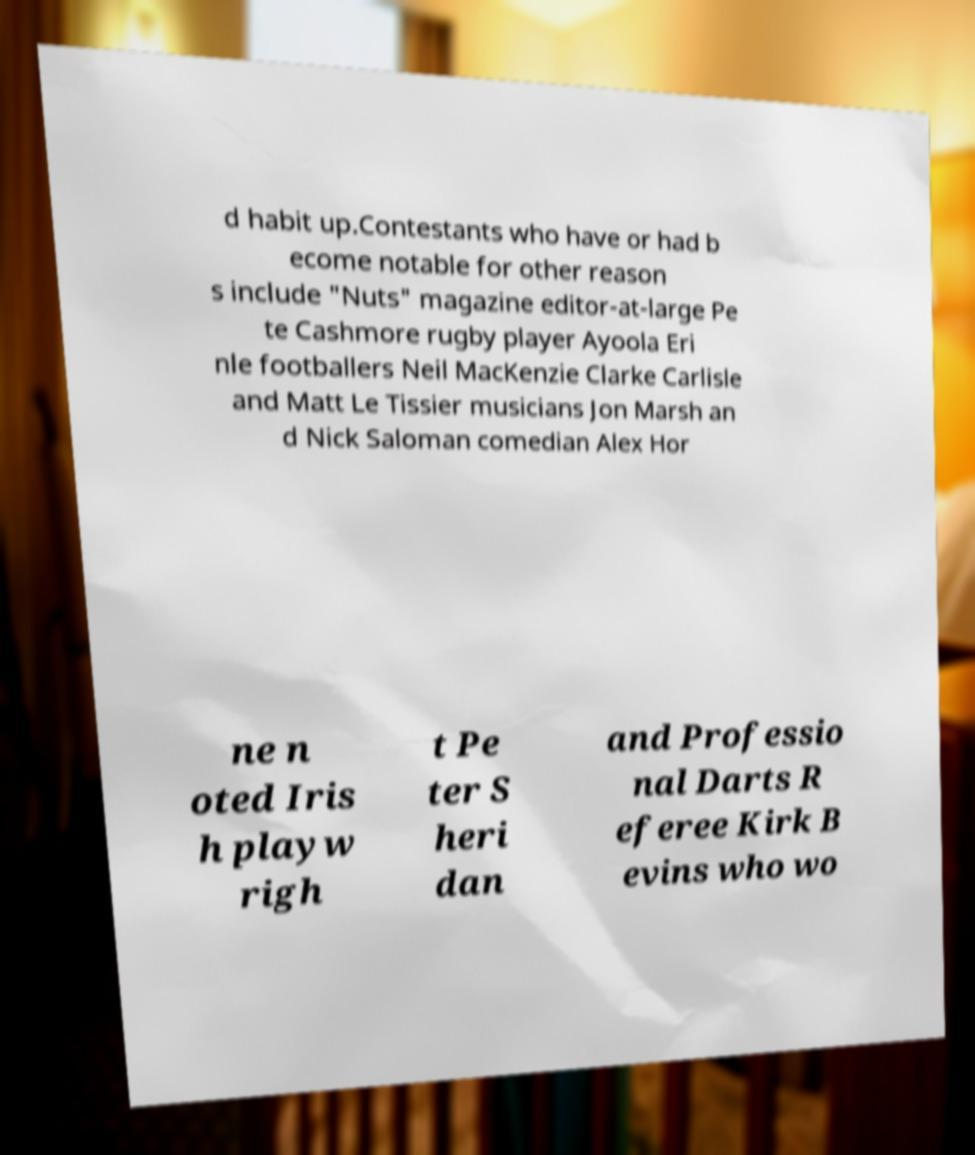Could you extract and type out the text from this image? d habit up.Contestants who have or had b ecome notable for other reason s include "Nuts" magazine editor-at-large Pe te Cashmore rugby player Ayoola Eri nle footballers Neil MacKenzie Clarke Carlisle and Matt Le Tissier musicians Jon Marsh an d Nick Saloman comedian Alex Hor ne n oted Iris h playw righ t Pe ter S heri dan and Professio nal Darts R eferee Kirk B evins who wo 